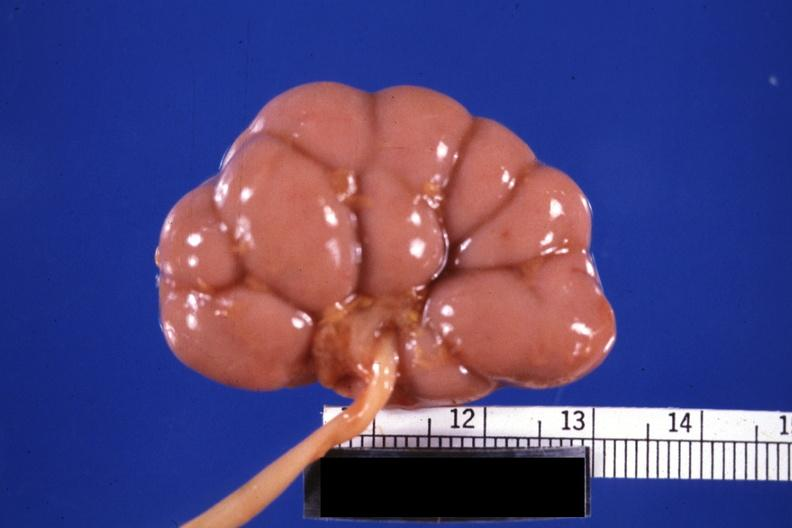s marked present?
Answer the question using a single word or phrase. No 